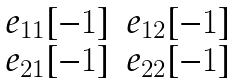Convert formula to latex. <formula><loc_0><loc_0><loc_500><loc_500>\begin{matrix} e _ { 1 1 } [ - 1 ] & e _ { 1 2 } [ - 1 ] \\ e _ { 2 1 } [ - 1 ] & e _ { 2 2 } [ - 1 ] \end{matrix}</formula> 